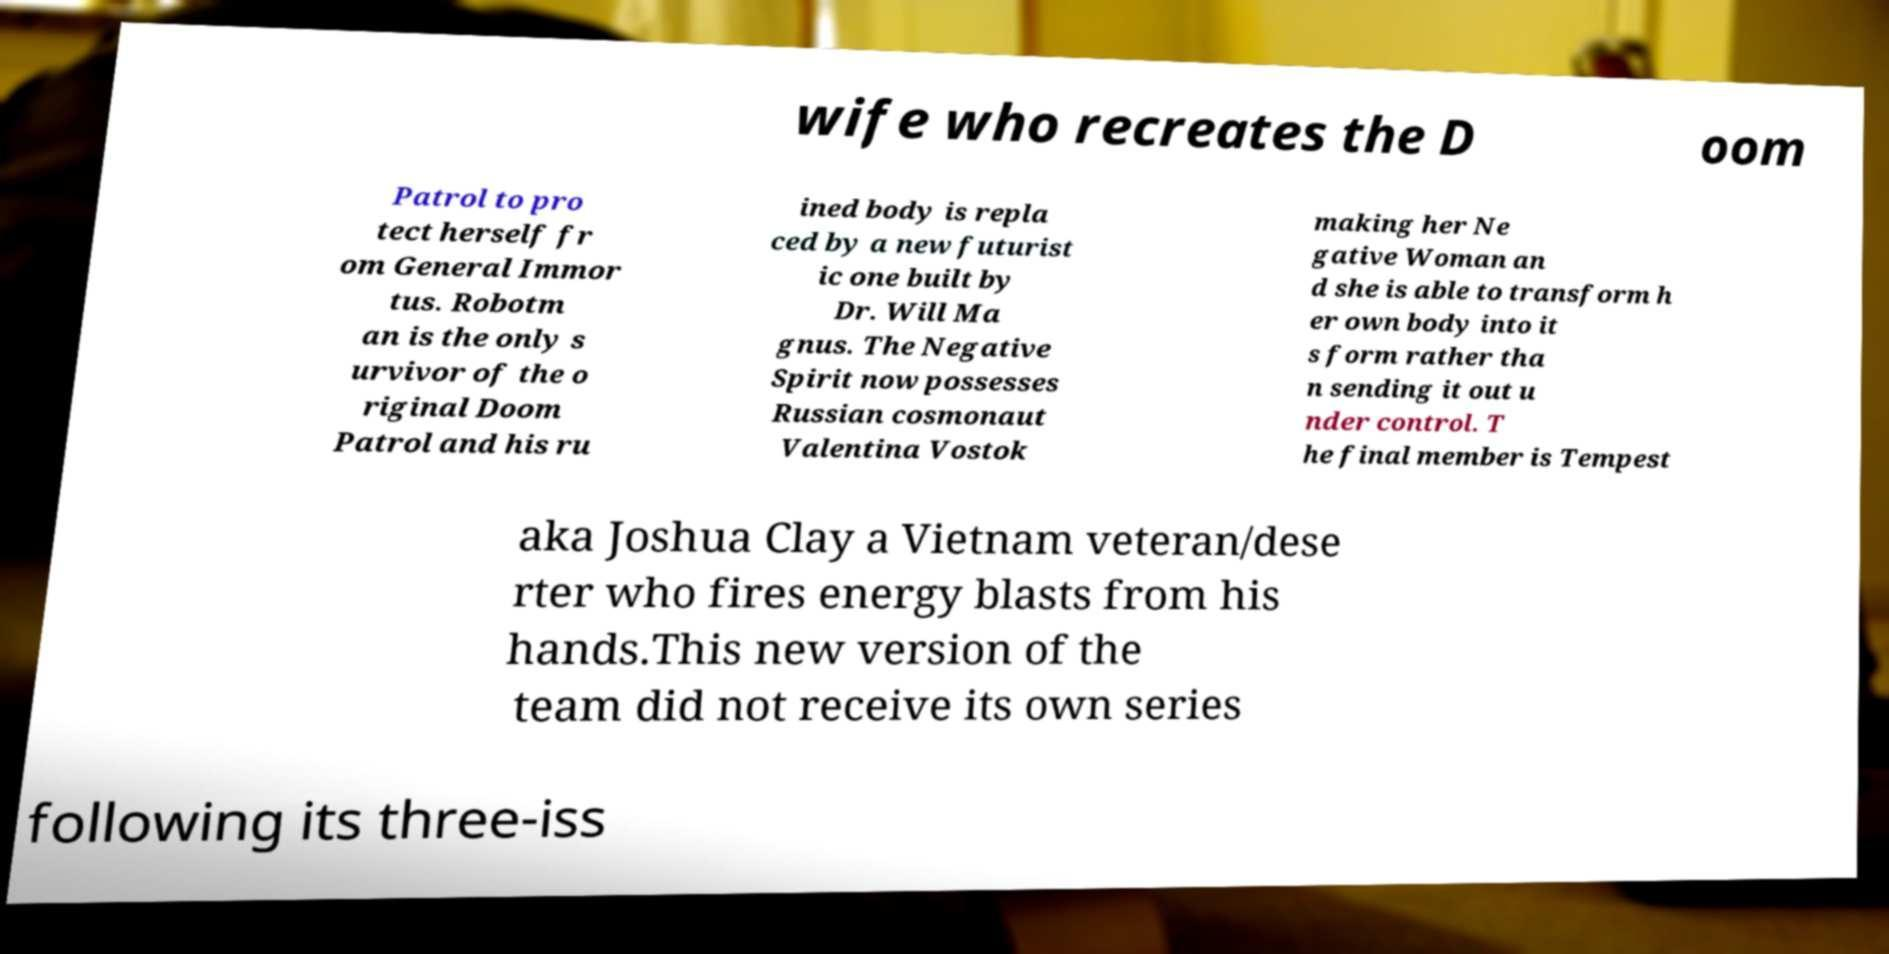Could you extract and type out the text from this image? wife who recreates the D oom Patrol to pro tect herself fr om General Immor tus. Robotm an is the only s urvivor of the o riginal Doom Patrol and his ru ined body is repla ced by a new futurist ic one built by Dr. Will Ma gnus. The Negative Spirit now possesses Russian cosmonaut Valentina Vostok making her Ne gative Woman an d she is able to transform h er own body into it s form rather tha n sending it out u nder control. T he final member is Tempest aka Joshua Clay a Vietnam veteran/dese rter who fires energy blasts from his hands.This new version of the team did not receive its own series following its three-iss 